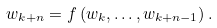<formula> <loc_0><loc_0><loc_500><loc_500>w _ { k + n } = f \left ( w _ { k } , \dots , w _ { k + n - 1 } \right ) .</formula> 